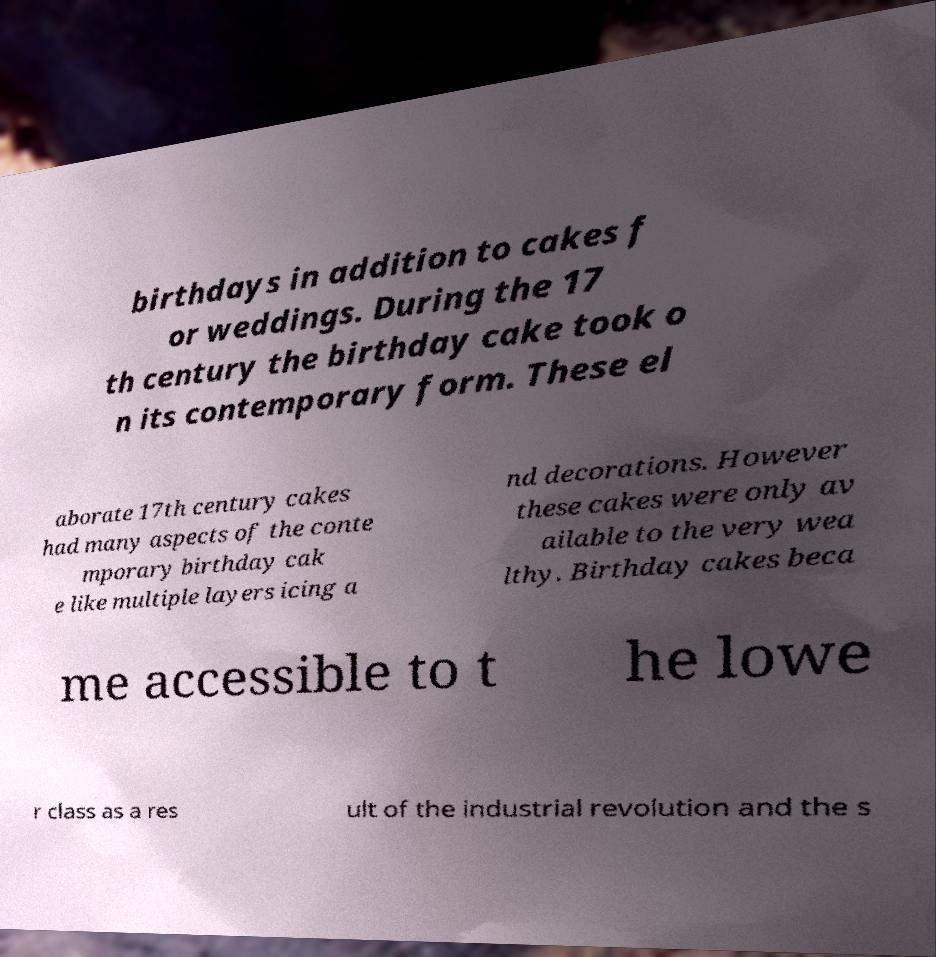I need the written content from this picture converted into text. Can you do that? birthdays in addition to cakes f or weddings. During the 17 th century the birthday cake took o n its contemporary form. These el aborate 17th century cakes had many aspects of the conte mporary birthday cak e like multiple layers icing a nd decorations. However these cakes were only av ailable to the very wea lthy. Birthday cakes beca me accessible to t he lowe r class as a res ult of the industrial revolution and the s 